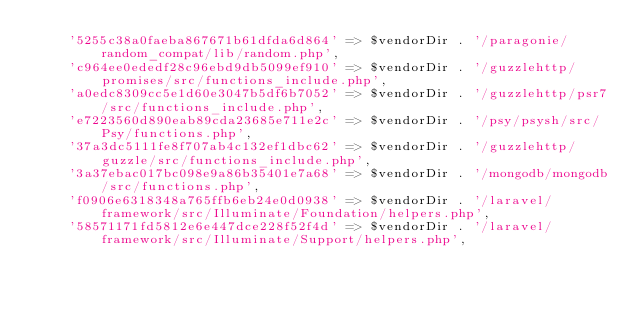<code> <loc_0><loc_0><loc_500><loc_500><_PHP_>    '5255c38a0faeba867671b61dfda6d864' => $vendorDir . '/paragonie/random_compat/lib/random.php',
    'c964ee0ededf28c96ebd9db5099ef910' => $vendorDir . '/guzzlehttp/promises/src/functions_include.php',
    'a0edc8309cc5e1d60e3047b5df6b7052' => $vendorDir . '/guzzlehttp/psr7/src/functions_include.php',
    'e7223560d890eab89cda23685e711e2c' => $vendorDir . '/psy/psysh/src/Psy/functions.php',
    '37a3dc5111fe8f707ab4c132ef1dbc62' => $vendorDir . '/guzzlehttp/guzzle/src/functions_include.php',
    '3a37ebac017bc098e9a86b35401e7a68' => $vendorDir . '/mongodb/mongodb/src/functions.php',
    'f0906e6318348a765ffb6eb24e0d0938' => $vendorDir . '/laravel/framework/src/Illuminate/Foundation/helpers.php',
    '58571171fd5812e6e447dce228f52f4d' => $vendorDir . '/laravel/framework/src/Illuminate/Support/helpers.php',</code> 